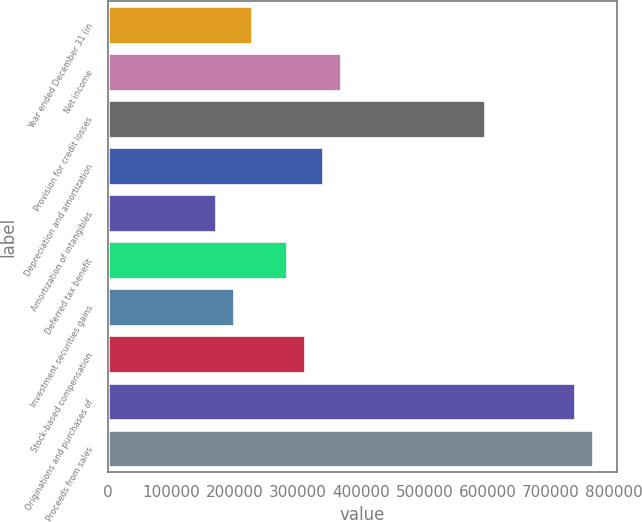Convert chart to OTSL. <chart><loc_0><loc_0><loc_500><loc_500><bar_chart><fcel>Year ended December 31 (in<fcel>Net income<fcel>Provision for credit losses<fcel>Depreciation and amortization<fcel>Amortization of intangibles<fcel>Deferred tax benefit<fcel>Investment securities gains<fcel>Stock-based compensation<fcel>Originations and purchases of<fcel>Proceeds from sales<nl><fcel>226939<fcel>368769<fcel>595698<fcel>340403<fcel>170207<fcel>283671<fcel>198573<fcel>312037<fcel>737529<fcel>765895<nl></chart> 